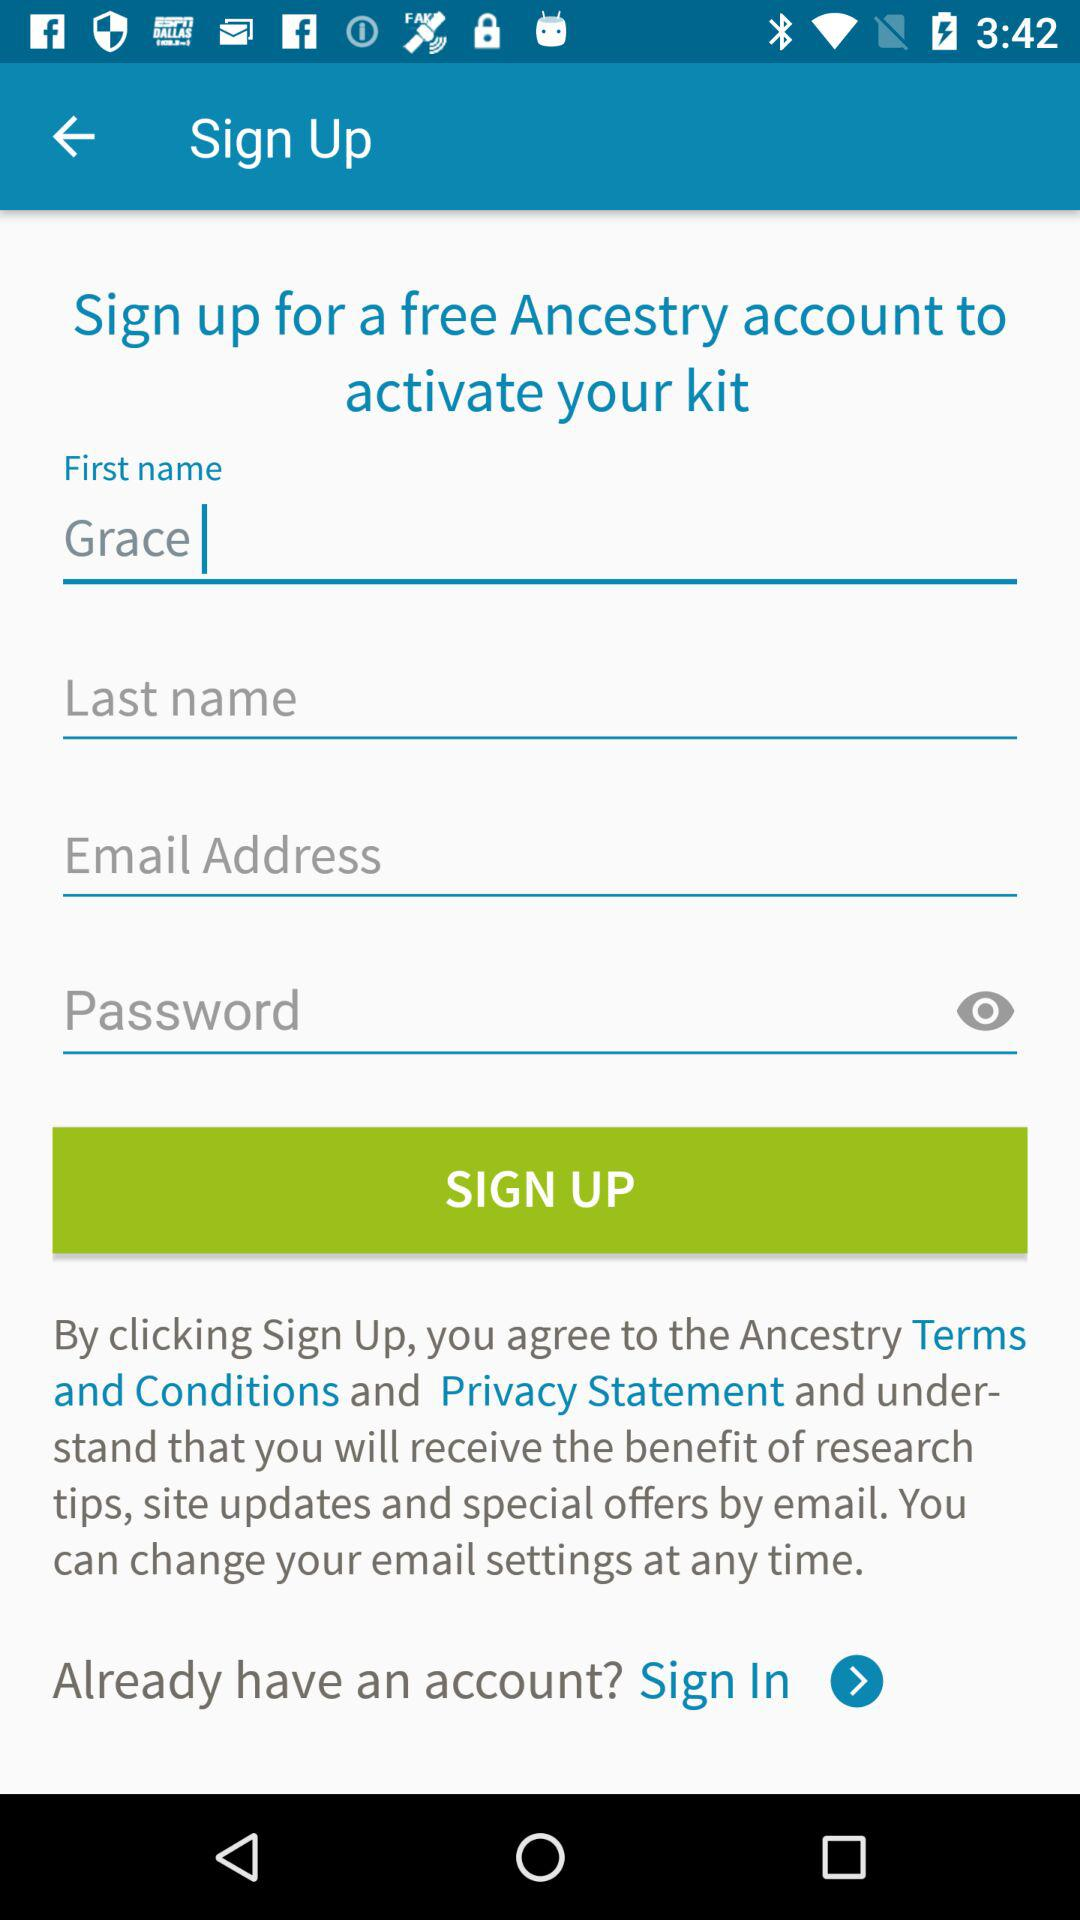What is the first name? The first name is Grace. 